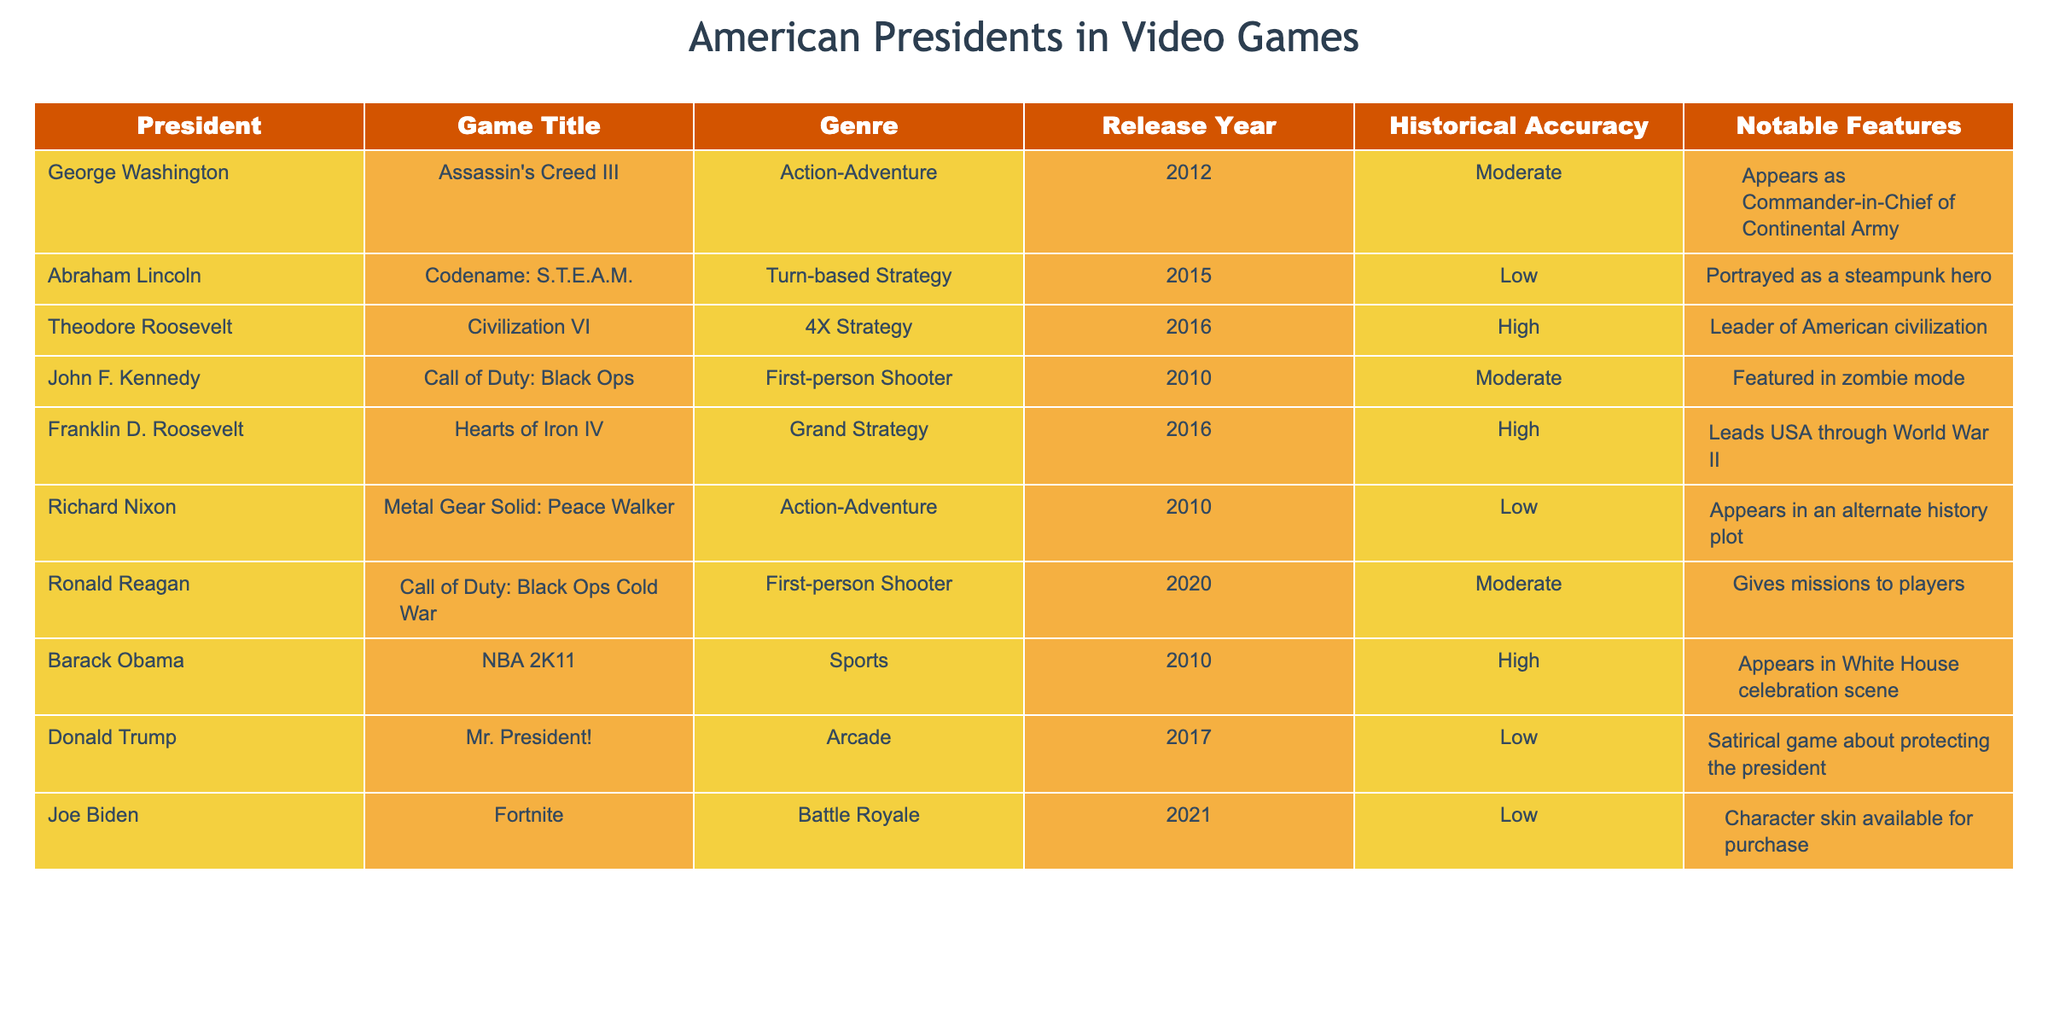What video game features George Washington? The table lists "Assassin's Creed III" as the game featuring George Washington.
Answer: Assassin's Creed III Which president is portrayed as a steampunk hero in a video game? The table indicates that Abraham Lincoln is portrayed as a steampunk hero in "Codename: S.T.E.A.M."
Answer: Abraham Lincoln How many presidents are featured in first-person shooters? There are three first-person shooter games listed for presidents: "Call of Duty: Black Ops" (John F. Kennedy), "Call of Duty: Black Ops Cold War" (Ronald Reagan), and "Metal Gear Solid: Peace Walker" (Richard Nixon), totaling three presidents.
Answer: 3 Is Franklin D. Roosevelt depicted accurately in video games? The table states that Franklin D. Roosevelt has high historical accuracy in "Hearts of Iron IV."
Answer: Yes Which president appears in a sports video game? According to the table, Barack Obama appears in "NBA 2K11," which is a sports video game.
Answer: Barack Obama Among the listed presidents, who leads the USA through World War II according to the game? Franklin D. Roosevelt is mentioned as leading the USA during World War II in "Hearts of Iron IV."
Answer: Franklin D. Roosevelt What is the notable feature of the game featuring Donald Trump? The notable feature of "Mr. President!" is its satirical nature about protecting the president.
Answer: Satirical game about protecting the president Which president appears in a character skin available for purchase? Joe Biden appears as a character skin available for purchase in "Fortnite".
Answer: Joe Biden What is the average historical accuracy rating for the presidents in the table? The historical accuracy ratings are: Moderate (3), Low (4), High (3). Converting these into values: Moderate = 2, Low = 1, High = 3 gives (3*2 + 4*1 + 3*3) / 10 = 1.8, meaning the average is 1.8.
Answer: 1.8 